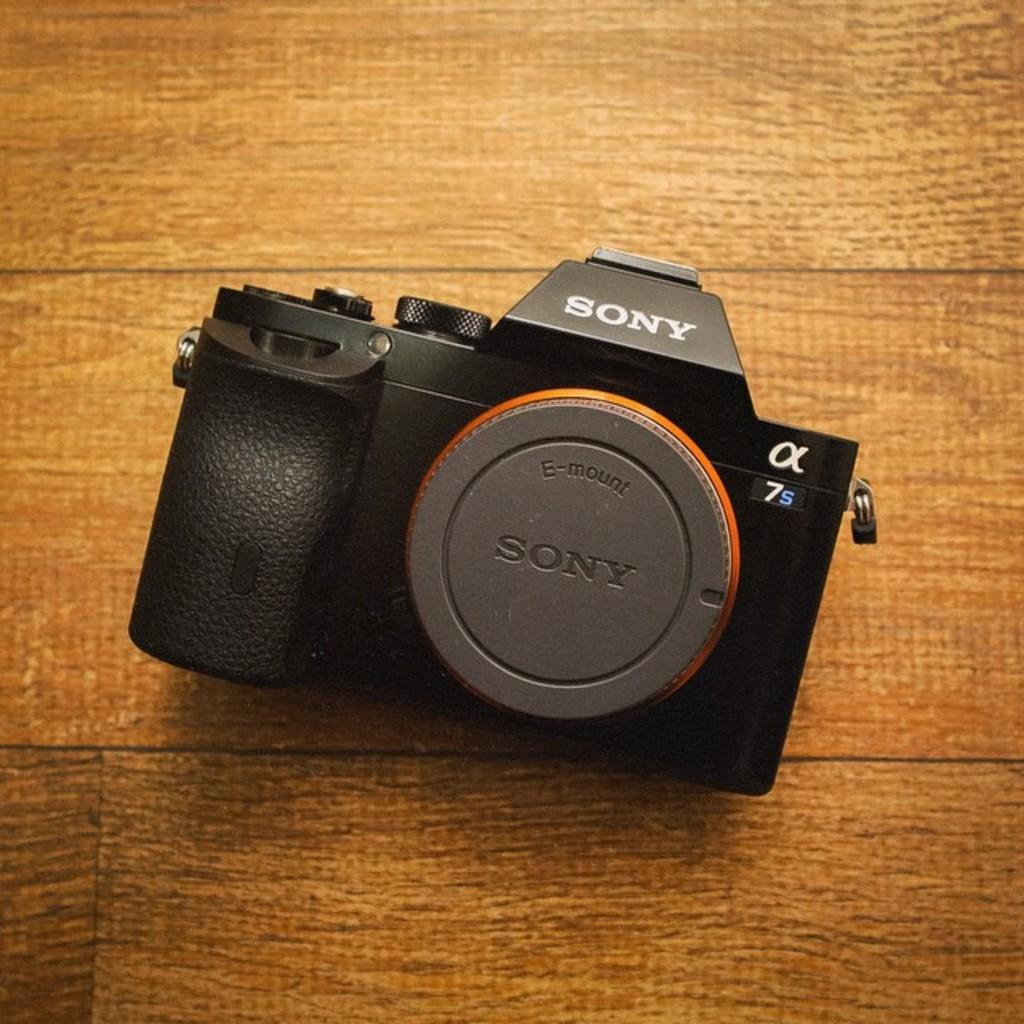<image>
Offer a succinct explanation of the picture presented. A Sony 7s camera has the lens on it 